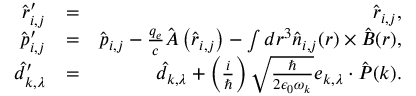<formula> <loc_0><loc_0><loc_500><loc_500>\begin{array} { r l r } { \hat { \boldsymbol r } _ { i , j } ^ { \prime } } & { = } & { \hat { \boldsymbol r } _ { i , j } , } \\ { \hat { \boldsymbol p } _ { i , j } ^ { \prime } } & { = } & { \hat { \boldsymbol p } _ { i , j } - \frac { q _ { e } } { c } \hat { \boldsymbol A } \left ( \hat { \boldsymbol r } _ { i , j } \right ) - \int d \boldsymbol r ^ { 3 } \hat { \boldsymbol n } _ { i , j } ( \boldsymbol r ) \times \hat { \boldsymbol B } ( \boldsymbol r ) , } \\ { \hat { d } _ { \boldsymbol k , \lambda } ^ { \prime } } & { = } & { \hat { d } _ { \boldsymbol k , \lambda } + \left ( \frac { i } { } \right ) \sqrt { \frac { } { 2 \epsilon _ { 0 } \omega _ { \boldsymbol k } } } { \boldsymbol e } _ { \boldsymbol k , \lambda } \cdot \hat { \boldsymbol P } ( \boldsymbol k ) . } \end{array}</formula> 